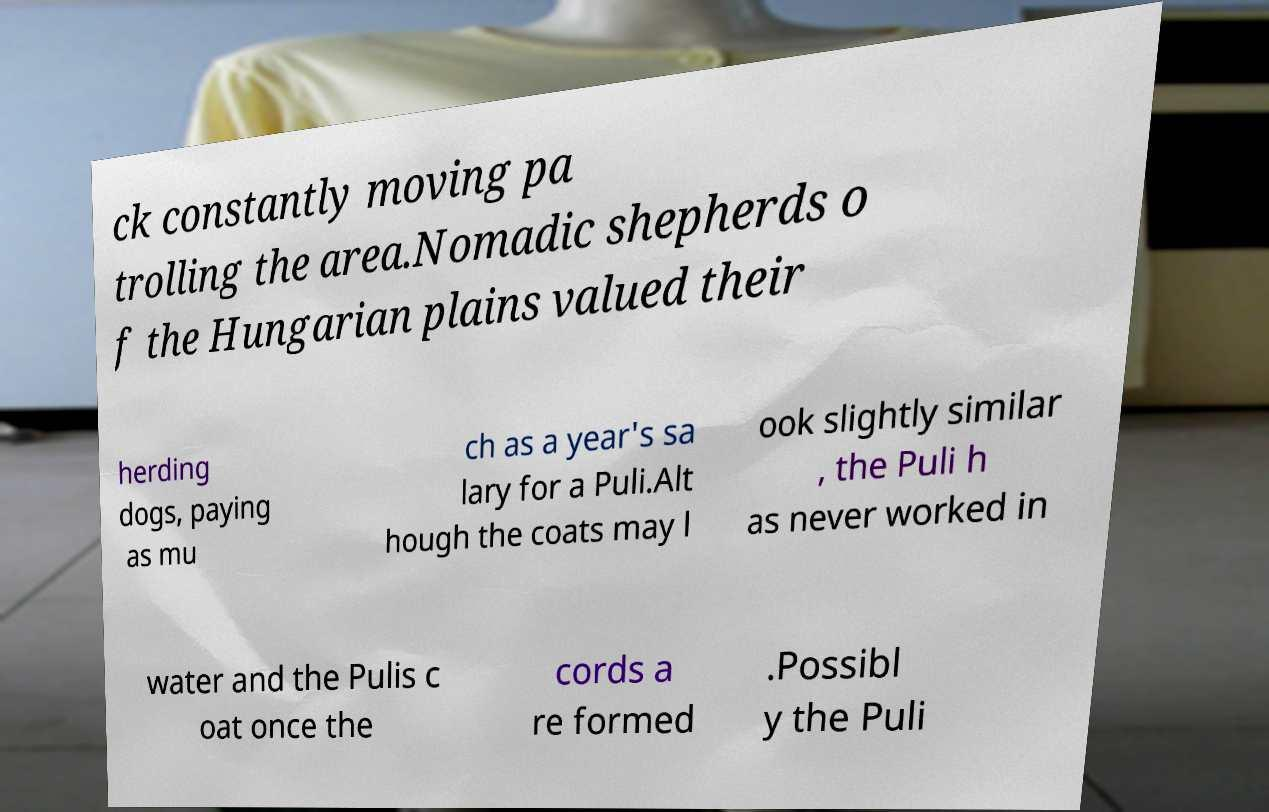Please read and relay the text visible in this image. What does it say? ck constantly moving pa trolling the area.Nomadic shepherds o f the Hungarian plains valued their herding dogs, paying as mu ch as a year's sa lary for a Puli.Alt hough the coats may l ook slightly similar , the Puli h as never worked in water and the Pulis c oat once the cords a re formed .Possibl y the Puli 